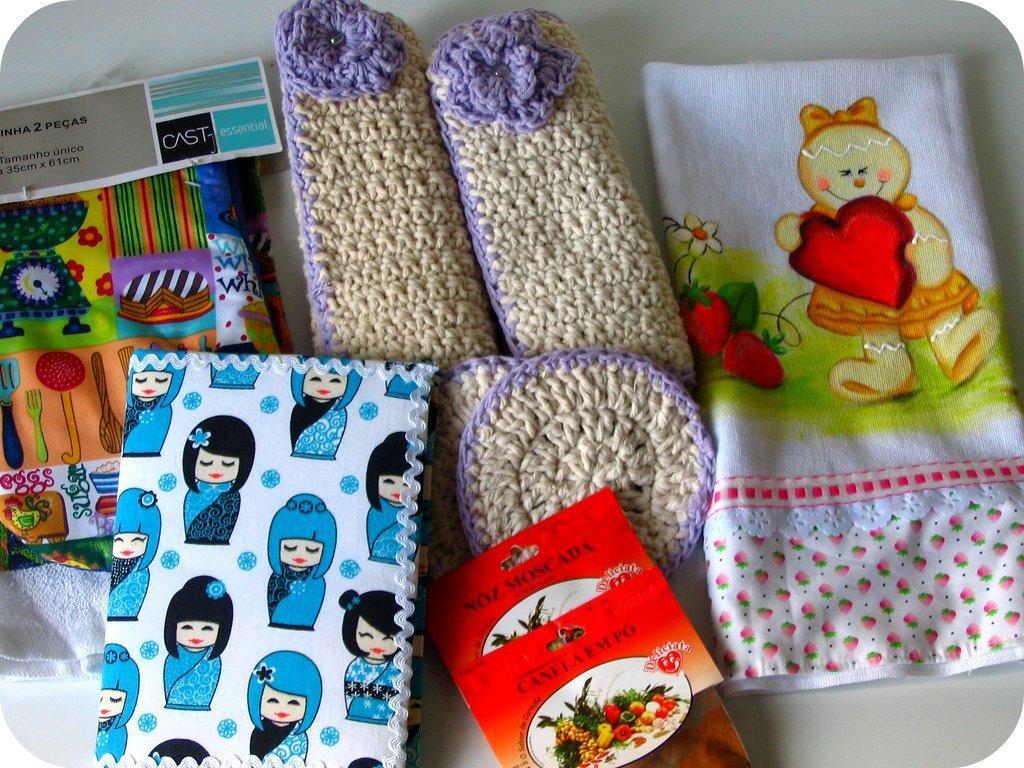Describe this image in one or two sentences. This picture consists of baby accessories. This is a cloth. These are the woolen shoes. This is a packet. This is , i guess it's a book. This is also a piece of cloth. 